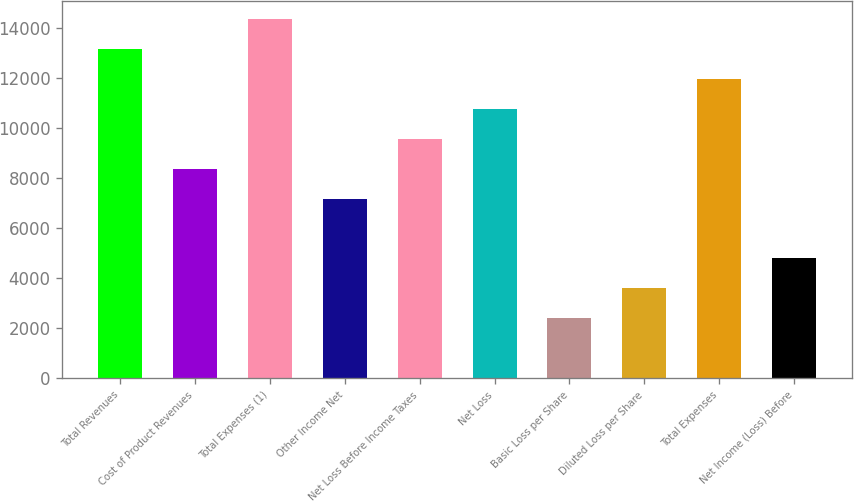Convert chart to OTSL. <chart><loc_0><loc_0><loc_500><loc_500><bar_chart><fcel>Total Revenues<fcel>Cost of Product Revenues<fcel>Total Expenses (1)<fcel>Other Income Net<fcel>Net Loss Before Income Taxes<fcel>Net Loss<fcel>Basic Loss per Share<fcel>Diluted Loss per Share<fcel>Total Expenses<fcel>Net Income (Loss) Before<nl><fcel>13183.5<fcel>8389.51<fcel>14382<fcel>7191.01<fcel>9588.01<fcel>10786.5<fcel>2397.01<fcel>3595.51<fcel>11985<fcel>4794.01<nl></chart> 